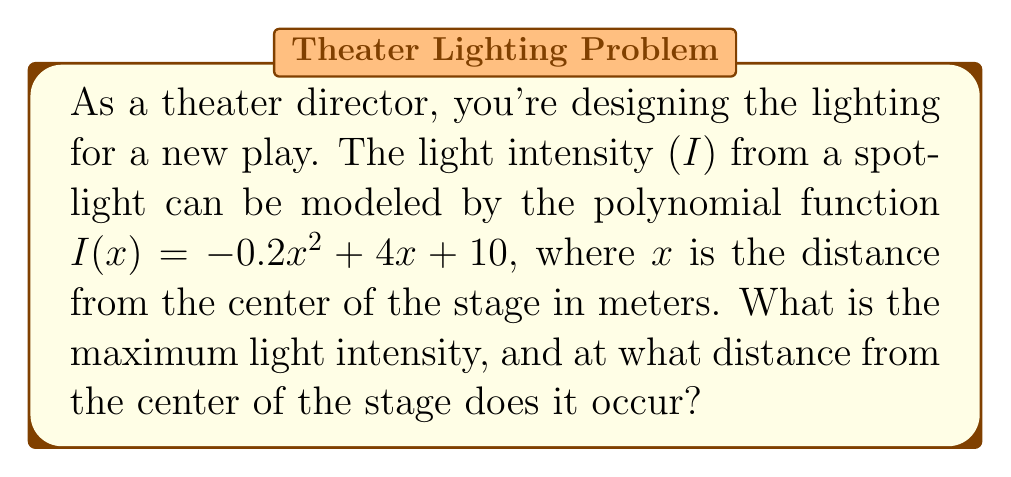Help me with this question. To find the maximum light intensity and its corresponding distance, we need to follow these steps:

1. The given polynomial function is quadratic: $I(x) = -0.2x^2 + 4x + 10$

2. For a quadratic function $f(x) = ax^2 + bx + c$, the vertex form is:
   $f(x) = a(x - h)^2 + k$
   where $(h, k)$ is the vertex of the parabola.

3. To find h (x-coordinate of the vertex):
   $h = -\frac{b}{2a} = -\frac{4}{2(-0.2)} = -\frac{4}{-0.4} = 10$

4. To find k (y-coordinate of the vertex), substitute x = 10 into the original function:
   $I(10) = -0.2(10)^2 + 4(10) + 10$
   $= -0.2(100) + 40 + 10$
   $= -20 + 40 + 10 = 30$

5. The vertex $(10, 30)$ represents the maximum point of the parabola since $a = -0.2 < 0$ (parabola opens downward).

Therefore, the maximum light intensity is 30 units, occurring at a distance of 10 meters from the center of the stage.
Answer: Maximum intensity: 30 units; Distance: 10 meters 